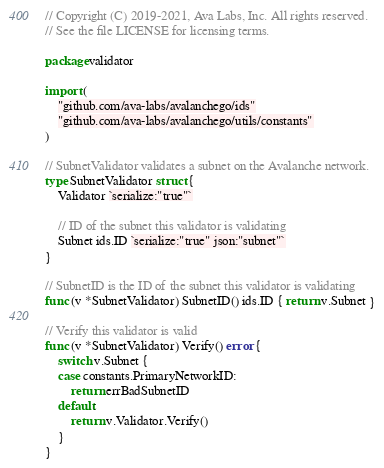Convert code to text. <code><loc_0><loc_0><loc_500><loc_500><_Go_>// Copyright (C) 2019-2021, Ava Labs, Inc. All rights reserved.
// See the file LICENSE for licensing terms.

package validator

import (
	"github.com/ava-labs/avalanchego/ids"
	"github.com/ava-labs/avalanchego/utils/constants"
)

// SubnetValidator validates a subnet on the Avalanche network.
type SubnetValidator struct {
	Validator `serialize:"true"`

	// ID of the subnet this validator is validating
	Subnet ids.ID `serialize:"true" json:"subnet"`
}

// SubnetID is the ID of the subnet this validator is validating
func (v *SubnetValidator) SubnetID() ids.ID { return v.Subnet }

// Verify this validator is valid
func (v *SubnetValidator) Verify() error {
	switch v.Subnet {
	case constants.PrimaryNetworkID:
		return errBadSubnetID
	default:
		return v.Validator.Verify()
	}
}
</code> 